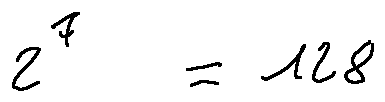<formula> <loc_0><loc_0><loc_500><loc_500>2 ^ { 7 } = 1 2 8</formula> 